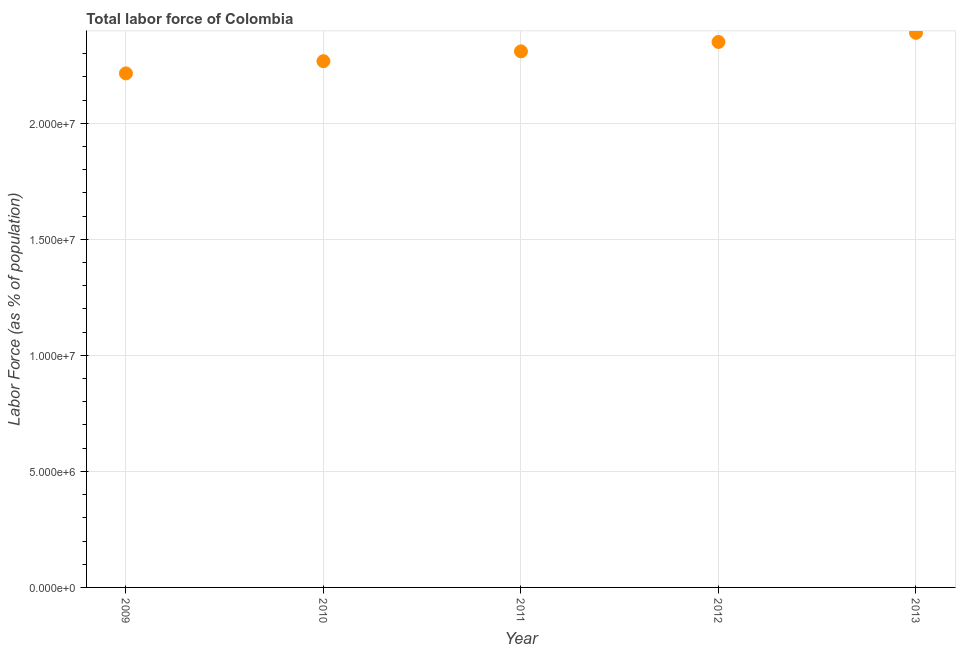What is the total labor force in 2011?
Your answer should be very brief. 2.31e+07. Across all years, what is the maximum total labor force?
Offer a terse response. 2.39e+07. Across all years, what is the minimum total labor force?
Offer a terse response. 2.22e+07. What is the sum of the total labor force?
Give a very brief answer. 1.15e+08. What is the difference between the total labor force in 2010 and 2013?
Your answer should be very brief. -1.22e+06. What is the average total labor force per year?
Provide a succinct answer. 2.31e+07. What is the median total labor force?
Offer a terse response. 2.31e+07. What is the ratio of the total labor force in 2010 to that in 2012?
Offer a very short reply. 0.96. Is the total labor force in 2009 less than that in 2013?
Your answer should be very brief. Yes. Is the difference between the total labor force in 2009 and 2011 greater than the difference between any two years?
Provide a short and direct response. No. What is the difference between the highest and the second highest total labor force?
Your answer should be very brief. 3.92e+05. Is the sum of the total labor force in 2011 and 2013 greater than the maximum total labor force across all years?
Offer a very short reply. Yes. What is the difference between the highest and the lowest total labor force?
Your answer should be compact. 1.75e+06. Does the total labor force monotonically increase over the years?
Offer a terse response. Yes. Does the graph contain any zero values?
Provide a short and direct response. No. Does the graph contain grids?
Your answer should be very brief. Yes. What is the title of the graph?
Provide a succinct answer. Total labor force of Colombia. What is the label or title of the X-axis?
Give a very brief answer. Year. What is the label or title of the Y-axis?
Keep it short and to the point. Labor Force (as % of population). What is the Labor Force (as % of population) in 2009?
Make the answer very short. 2.22e+07. What is the Labor Force (as % of population) in 2010?
Your response must be concise. 2.27e+07. What is the Labor Force (as % of population) in 2011?
Offer a very short reply. 2.31e+07. What is the Labor Force (as % of population) in 2012?
Your answer should be compact. 2.35e+07. What is the Labor Force (as % of population) in 2013?
Keep it short and to the point. 2.39e+07. What is the difference between the Labor Force (as % of population) in 2009 and 2010?
Offer a terse response. -5.27e+05. What is the difference between the Labor Force (as % of population) in 2009 and 2011?
Make the answer very short. -9.50e+05. What is the difference between the Labor Force (as % of population) in 2009 and 2012?
Your answer should be compact. -1.36e+06. What is the difference between the Labor Force (as % of population) in 2009 and 2013?
Offer a terse response. -1.75e+06. What is the difference between the Labor Force (as % of population) in 2010 and 2011?
Offer a very short reply. -4.23e+05. What is the difference between the Labor Force (as % of population) in 2010 and 2012?
Offer a terse response. -8.28e+05. What is the difference between the Labor Force (as % of population) in 2010 and 2013?
Your response must be concise. -1.22e+06. What is the difference between the Labor Force (as % of population) in 2011 and 2012?
Offer a very short reply. -4.05e+05. What is the difference between the Labor Force (as % of population) in 2011 and 2013?
Offer a terse response. -7.97e+05. What is the difference between the Labor Force (as % of population) in 2012 and 2013?
Provide a short and direct response. -3.92e+05. What is the ratio of the Labor Force (as % of population) in 2009 to that in 2010?
Your response must be concise. 0.98. What is the ratio of the Labor Force (as % of population) in 2009 to that in 2012?
Your response must be concise. 0.94. What is the ratio of the Labor Force (as % of population) in 2009 to that in 2013?
Ensure brevity in your answer.  0.93. What is the ratio of the Labor Force (as % of population) in 2010 to that in 2011?
Give a very brief answer. 0.98. What is the ratio of the Labor Force (as % of population) in 2010 to that in 2012?
Offer a very short reply. 0.96. What is the ratio of the Labor Force (as % of population) in 2010 to that in 2013?
Offer a terse response. 0.95. What is the ratio of the Labor Force (as % of population) in 2011 to that in 2012?
Offer a terse response. 0.98. What is the ratio of the Labor Force (as % of population) in 2011 to that in 2013?
Keep it short and to the point. 0.97. What is the ratio of the Labor Force (as % of population) in 2012 to that in 2013?
Provide a succinct answer. 0.98. 